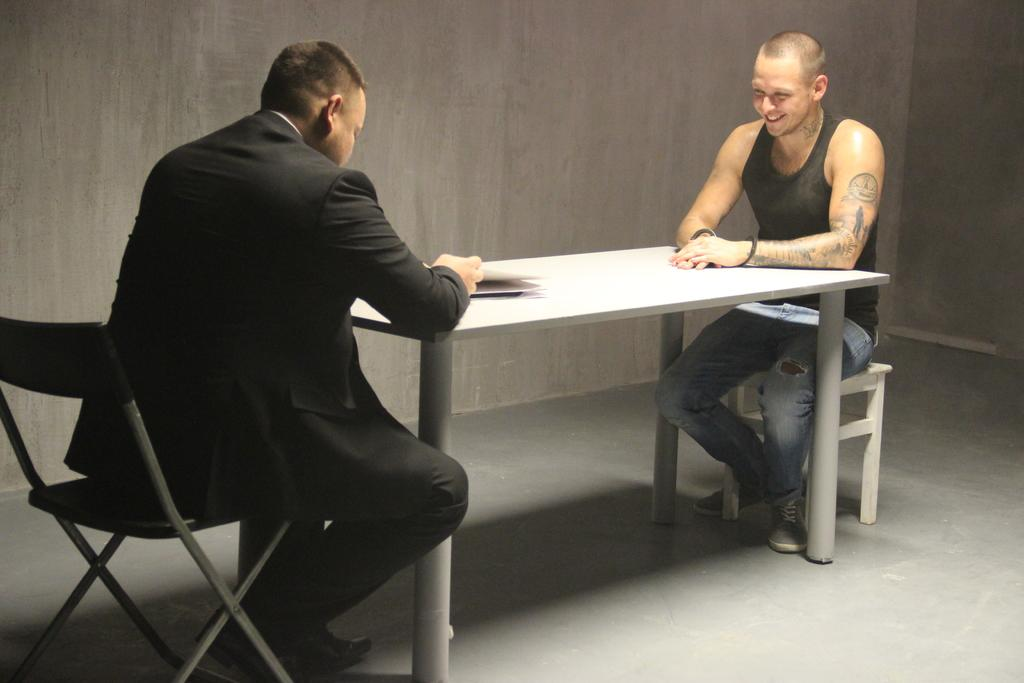How many people are in the image? There are two men in the image. What are the men doing in the image? The men are sitting on chairs. How are the chairs arranged in the image? The chairs are positioned opposite to each other. What is on the table in the image? The table has paper on it. What type of surface is visible in the image? There is a wall and a floor in the image. What type of pipe can be seen hanging on the wall in the image? There is no pipe visible on the wall in the image. What time is indicated by the clock in the image? There is no clock present in the image. 